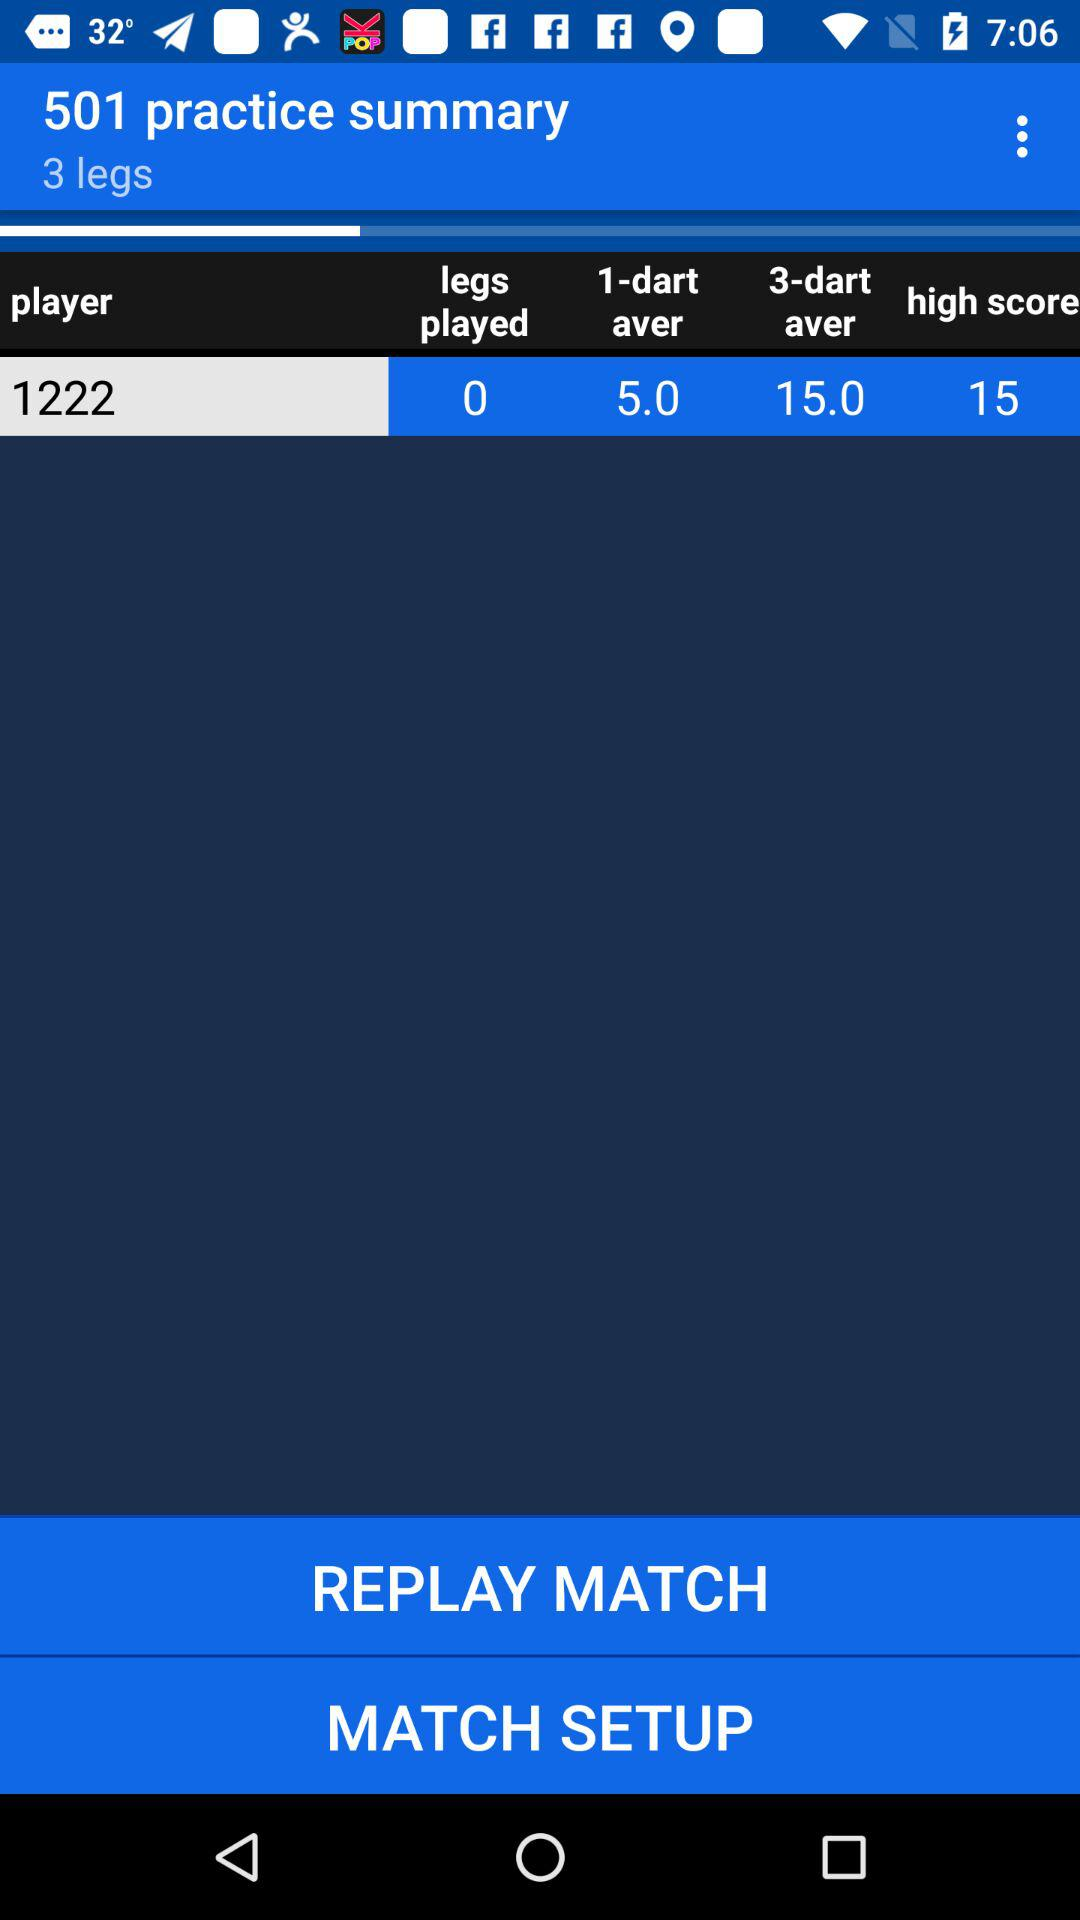What is the highest score? The highest score is 15. 